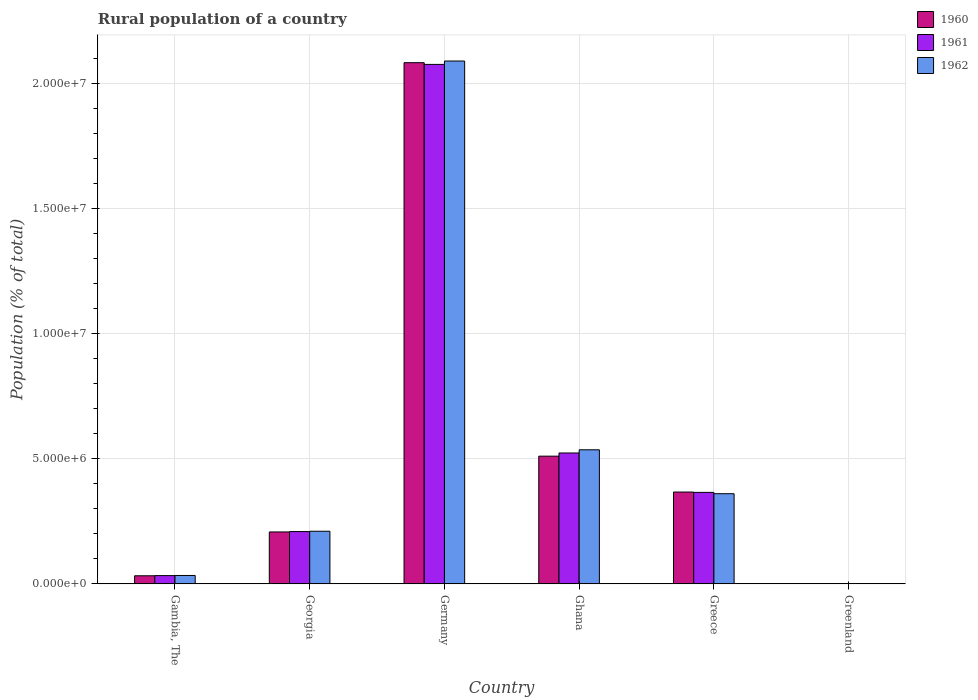Are the number of bars on each tick of the X-axis equal?
Keep it short and to the point. Yes. How many bars are there on the 1st tick from the right?
Give a very brief answer. 3. In how many cases, is the number of bars for a given country not equal to the number of legend labels?
Provide a succinct answer. 0. What is the rural population in 1962 in Ghana?
Give a very brief answer. 5.36e+06. Across all countries, what is the maximum rural population in 1962?
Ensure brevity in your answer.  2.09e+07. Across all countries, what is the minimum rural population in 1962?
Offer a very short reply. 1.35e+04. In which country was the rural population in 1960 maximum?
Make the answer very short. Germany. In which country was the rural population in 1962 minimum?
Make the answer very short. Greenland. What is the total rural population in 1961 in the graph?
Your answer should be very brief. 3.21e+07. What is the difference between the rural population in 1960 in Gambia, The and that in Greenland?
Your response must be concise. 3.10e+05. What is the difference between the rural population in 1960 in Greenland and the rural population in 1962 in Gambia, The?
Make the answer very short. -3.22e+05. What is the average rural population in 1960 per country?
Your answer should be very brief. 5.34e+06. What is the difference between the rural population of/in 1960 and rural population of/in 1962 in Gambia, The?
Your answer should be compact. -1.21e+04. What is the ratio of the rural population in 1960 in Gambia, The to that in Greece?
Offer a very short reply. 0.09. Is the rural population in 1962 in Georgia less than that in Germany?
Your answer should be very brief. Yes. What is the difference between the highest and the second highest rural population in 1962?
Keep it short and to the point. -1.73e+07. What is the difference between the highest and the lowest rural population in 1961?
Keep it short and to the point. 2.08e+07. In how many countries, is the rural population in 1960 greater than the average rural population in 1960 taken over all countries?
Make the answer very short. 1. What does the 1st bar from the left in Greece represents?
Provide a succinct answer. 1960. How many bars are there?
Offer a terse response. 18. Are all the bars in the graph horizontal?
Make the answer very short. No. Are the values on the major ticks of Y-axis written in scientific E-notation?
Your answer should be very brief. Yes. Does the graph contain any zero values?
Your response must be concise. No. Does the graph contain grids?
Provide a short and direct response. Yes. Where does the legend appear in the graph?
Keep it short and to the point. Top right. How many legend labels are there?
Offer a very short reply. 3. What is the title of the graph?
Provide a short and direct response. Rural population of a country. What is the label or title of the Y-axis?
Offer a terse response. Population (% of total). What is the Population (% of total) of 1960 in Gambia, The?
Make the answer very short. 3.23e+05. What is the Population (% of total) of 1961 in Gambia, The?
Keep it short and to the point. 3.30e+05. What is the Population (% of total) of 1962 in Gambia, The?
Your answer should be very brief. 3.35e+05. What is the Population (% of total) in 1960 in Georgia?
Your answer should be compact. 2.08e+06. What is the Population (% of total) of 1961 in Georgia?
Offer a terse response. 2.09e+06. What is the Population (% of total) of 1962 in Georgia?
Make the answer very short. 2.10e+06. What is the Population (% of total) of 1960 in Germany?
Offer a terse response. 2.08e+07. What is the Population (% of total) of 1961 in Germany?
Keep it short and to the point. 2.08e+07. What is the Population (% of total) of 1962 in Germany?
Provide a short and direct response. 2.09e+07. What is the Population (% of total) in 1960 in Ghana?
Ensure brevity in your answer.  5.11e+06. What is the Population (% of total) of 1961 in Ghana?
Keep it short and to the point. 5.23e+06. What is the Population (% of total) of 1962 in Ghana?
Offer a very short reply. 5.36e+06. What is the Population (% of total) in 1960 in Greece?
Your answer should be very brief. 3.67e+06. What is the Population (% of total) in 1961 in Greece?
Make the answer very short. 3.66e+06. What is the Population (% of total) of 1962 in Greece?
Keep it short and to the point. 3.60e+06. What is the Population (% of total) in 1960 in Greenland?
Your answer should be very brief. 1.35e+04. What is the Population (% of total) in 1961 in Greenland?
Your answer should be very brief. 1.35e+04. What is the Population (% of total) in 1962 in Greenland?
Offer a very short reply. 1.35e+04. Across all countries, what is the maximum Population (% of total) in 1960?
Keep it short and to the point. 2.08e+07. Across all countries, what is the maximum Population (% of total) in 1961?
Offer a very short reply. 2.08e+07. Across all countries, what is the maximum Population (% of total) in 1962?
Provide a short and direct response. 2.09e+07. Across all countries, what is the minimum Population (% of total) of 1960?
Offer a very short reply. 1.35e+04. Across all countries, what is the minimum Population (% of total) of 1961?
Your response must be concise. 1.35e+04. Across all countries, what is the minimum Population (% of total) of 1962?
Your response must be concise. 1.35e+04. What is the total Population (% of total) in 1960 in the graph?
Provide a short and direct response. 3.20e+07. What is the total Population (% of total) in 1961 in the graph?
Provide a succinct answer. 3.21e+07. What is the total Population (% of total) in 1962 in the graph?
Provide a succinct answer. 3.23e+07. What is the difference between the Population (% of total) of 1960 in Gambia, The and that in Georgia?
Your response must be concise. -1.75e+06. What is the difference between the Population (% of total) of 1961 in Gambia, The and that in Georgia?
Your response must be concise. -1.76e+06. What is the difference between the Population (% of total) in 1962 in Gambia, The and that in Georgia?
Your answer should be compact. -1.77e+06. What is the difference between the Population (% of total) of 1960 in Gambia, The and that in Germany?
Keep it short and to the point. -2.05e+07. What is the difference between the Population (% of total) of 1961 in Gambia, The and that in Germany?
Keep it short and to the point. -2.04e+07. What is the difference between the Population (% of total) of 1962 in Gambia, The and that in Germany?
Your response must be concise. -2.06e+07. What is the difference between the Population (% of total) of 1960 in Gambia, The and that in Ghana?
Provide a short and direct response. -4.78e+06. What is the difference between the Population (% of total) in 1961 in Gambia, The and that in Ghana?
Your response must be concise. -4.90e+06. What is the difference between the Population (% of total) of 1962 in Gambia, The and that in Ghana?
Provide a succinct answer. -5.02e+06. What is the difference between the Population (% of total) of 1960 in Gambia, The and that in Greece?
Make the answer very short. -3.35e+06. What is the difference between the Population (% of total) in 1961 in Gambia, The and that in Greece?
Your response must be concise. -3.33e+06. What is the difference between the Population (% of total) in 1962 in Gambia, The and that in Greece?
Provide a short and direct response. -3.27e+06. What is the difference between the Population (% of total) in 1960 in Gambia, The and that in Greenland?
Offer a very short reply. 3.10e+05. What is the difference between the Population (% of total) in 1961 in Gambia, The and that in Greenland?
Your answer should be very brief. 3.17e+05. What is the difference between the Population (% of total) of 1962 in Gambia, The and that in Greenland?
Give a very brief answer. 3.22e+05. What is the difference between the Population (% of total) of 1960 in Georgia and that in Germany?
Provide a succinct answer. -1.88e+07. What is the difference between the Population (% of total) in 1961 in Georgia and that in Germany?
Give a very brief answer. -1.87e+07. What is the difference between the Population (% of total) in 1962 in Georgia and that in Germany?
Offer a very short reply. -1.88e+07. What is the difference between the Population (% of total) of 1960 in Georgia and that in Ghana?
Your response must be concise. -3.03e+06. What is the difference between the Population (% of total) in 1961 in Georgia and that in Ghana?
Make the answer very short. -3.14e+06. What is the difference between the Population (% of total) in 1962 in Georgia and that in Ghana?
Your answer should be very brief. -3.26e+06. What is the difference between the Population (% of total) of 1960 in Georgia and that in Greece?
Ensure brevity in your answer.  -1.60e+06. What is the difference between the Population (% of total) in 1961 in Georgia and that in Greece?
Your answer should be very brief. -1.57e+06. What is the difference between the Population (% of total) of 1962 in Georgia and that in Greece?
Your answer should be very brief. -1.50e+06. What is the difference between the Population (% of total) in 1960 in Georgia and that in Greenland?
Keep it short and to the point. 2.06e+06. What is the difference between the Population (% of total) of 1961 in Georgia and that in Greenland?
Make the answer very short. 2.08e+06. What is the difference between the Population (% of total) in 1962 in Georgia and that in Greenland?
Make the answer very short. 2.09e+06. What is the difference between the Population (% of total) of 1960 in Germany and that in Ghana?
Provide a short and direct response. 1.57e+07. What is the difference between the Population (% of total) of 1961 in Germany and that in Ghana?
Offer a very short reply. 1.55e+07. What is the difference between the Population (% of total) in 1962 in Germany and that in Ghana?
Your response must be concise. 1.55e+07. What is the difference between the Population (% of total) of 1960 in Germany and that in Greece?
Ensure brevity in your answer.  1.72e+07. What is the difference between the Population (% of total) in 1961 in Germany and that in Greece?
Offer a terse response. 1.71e+07. What is the difference between the Population (% of total) of 1962 in Germany and that in Greece?
Keep it short and to the point. 1.73e+07. What is the difference between the Population (% of total) in 1960 in Germany and that in Greenland?
Your answer should be compact. 2.08e+07. What is the difference between the Population (% of total) in 1961 in Germany and that in Greenland?
Your answer should be compact. 2.08e+07. What is the difference between the Population (% of total) of 1962 in Germany and that in Greenland?
Keep it short and to the point. 2.09e+07. What is the difference between the Population (% of total) in 1960 in Ghana and that in Greece?
Make the answer very short. 1.43e+06. What is the difference between the Population (% of total) of 1961 in Ghana and that in Greece?
Keep it short and to the point. 1.58e+06. What is the difference between the Population (% of total) of 1962 in Ghana and that in Greece?
Make the answer very short. 1.76e+06. What is the difference between the Population (% of total) of 1960 in Ghana and that in Greenland?
Make the answer very short. 5.09e+06. What is the difference between the Population (% of total) of 1961 in Ghana and that in Greenland?
Make the answer very short. 5.22e+06. What is the difference between the Population (% of total) of 1962 in Ghana and that in Greenland?
Offer a terse response. 5.35e+06. What is the difference between the Population (% of total) in 1960 in Greece and that in Greenland?
Offer a terse response. 3.66e+06. What is the difference between the Population (% of total) in 1961 in Greece and that in Greenland?
Offer a terse response. 3.64e+06. What is the difference between the Population (% of total) of 1962 in Greece and that in Greenland?
Your answer should be very brief. 3.59e+06. What is the difference between the Population (% of total) in 1960 in Gambia, The and the Population (% of total) in 1961 in Georgia?
Provide a short and direct response. -1.77e+06. What is the difference between the Population (% of total) of 1960 in Gambia, The and the Population (% of total) of 1962 in Georgia?
Your response must be concise. -1.78e+06. What is the difference between the Population (% of total) in 1961 in Gambia, The and the Population (% of total) in 1962 in Georgia?
Ensure brevity in your answer.  -1.77e+06. What is the difference between the Population (% of total) in 1960 in Gambia, The and the Population (% of total) in 1961 in Germany?
Offer a terse response. -2.04e+07. What is the difference between the Population (% of total) in 1960 in Gambia, The and the Population (% of total) in 1962 in Germany?
Keep it short and to the point. -2.06e+07. What is the difference between the Population (% of total) in 1961 in Gambia, The and the Population (% of total) in 1962 in Germany?
Keep it short and to the point. -2.06e+07. What is the difference between the Population (% of total) in 1960 in Gambia, The and the Population (% of total) in 1961 in Ghana?
Your answer should be very brief. -4.91e+06. What is the difference between the Population (% of total) of 1960 in Gambia, The and the Population (% of total) of 1962 in Ghana?
Ensure brevity in your answer.  -5.04e+06. What is the difference between the Population (% of total) of 1961 in Gambia, The and the Population (% of total) of 1962 in Ghana?
Your answer should be compact. -5.03e+06. What is the difference between the Population (% of total) in 1960 in Gambia, The and the Population (% of total) in 1961 in Greece?
Make the answer very short. -3.33e+06. What is the difference between the Population (% of total) in 1960 in Gambia, The and the Population (% of total) in 1962 in Greece?
Provide a succinct answer. -3.28e+06. What is the difference between the Population (% of total) of 1961 in Gambia, The and the Population (% of total) of 1962 in Greece?
Offer a very short reply. -3.27e+06. What is the difference between the Population (% of total) of 1960 in Gambia, The and the Population (% of total) of 1961 in Greenland?
Offer a very short reply. 3.10e+05. What is the difference between the Population (% of total) in 1960 in Gambia, The and the Population (% of total) in 1962 in Greenland?
Provide a short and direct response. 3.10e+05. What is the difference between the Population (% of total) in 1961 in Gambia, The and the Population (% of total) in 1962 in Greenland?
Give a very brief answer. 3.17e+05. What is the difference between the Population (% of total) of 1960 in Georgia and the Population (% of total) of 1961 in Germany?
Provide a succinct answer. -1.87e+07. What is the difference between the Population (% of total) of 1960 in Georgia and the Population (% of total) of 1962 in Germany?
Ensure brevity in your answer.  -1.88e+07. What is the difference between the Population (% of total) of 1961 in Georgia and the Population (% of total) of 1962 in Germany?
Keep it short and to the point. -1.88e+07. What is the difference between the Population (% of total) of 1960 in Georgia and the Population (% of total) of 1961 in Ghana?
Provide a short and direct response. -3.16e+06. What is the difference between the Population (% of total) in 1960 in Georgia and the Population (% of total) in 1962 in Ghana?
Offer a very short reply. -3.28e+06. What is the difference between the Population (% of total) of 1961 in Georgia and the Population (% of total) of 1962 in Ghana?
Your answer should be very brief. -3.27e+06. What is the difference between the Population (% of total) of 1960 in Georgia and the Population (% of total) of 1961 in Greece?
Offer a terse response. -1.58e+06. What is the difference between the Population (% of total) of 1960 in Georgia and the Population (% of total) of 1962 in Greece?
Your answer should be very brief. -1.53e+06. What is the difference between the Population (% of total) of 1961 in Georgia and the Population (% of total) of 1962 in Greece?
Your response must be concise. -1.51e+06. What is the difference between the Population (% of total) of 1960 in Georgia and the Population (% of total) of 1961 in Greenland?
Your response must be concise. 2.06e+06. What is the difference between the Population (% of total) of 1960 in Georgia and the Population (% of total) of 1962 in Greenland?
Your answer should be compact. 2.06e+06. What is the difference between the Population (% of total) of 1961 in Georgia and the Population (% of total) of 1962 in Greenland?
Offer a very short reply. 2.08e+06. What is the difference between the Population (% of total) of 1960 in Germany and the Population (% of total) of 1961 in Ghana?
Your answer should be very brief. 1.56e+07. What is the difference between the Population (% of total) in 1960 in Germany and the Population (% of total) in 1962 in Ghana?
Provide a succinct answer. 1.55e+07. What is the difference between the Population (% of total) of 1961 in Germany and the Population (% of total) of 1962 in Ghana?
Offer a very short reply. 1.54e+07. What is the difference between the Population (% of total) in 1960 in Germany and the Population (% of total) in 1961 in Greece?
Keep it short and to the point. 1.72e+07. What is the difference between the Population (% of total) in 1960 in Germany and the Population (% of total) in 1962 in Greece?
Keep it short and to the point. 1.72e+07. What is the difference between the Population (% of total) in 1961 in Germany and the Population (% of total) in 1962 in Greece?
Offer a terse response. 1.72e+07. What is the difference between the Population (% of total) in 1960 in Germany and the Population (% of total) in 1961 in Greenland?
Your answer should be compact. 2.08e+07. What is the difference between the Population (% of total) of 1960 in Germany and the Population (% of total) of 1962 in Greenland?
Provide a succinct answer. 2.08e+07. What is the difference between the Population (% of total) of 1961 in Germany and the Population (% of total) of 1962 in Greenland?
Offer a very short reply. 2.08e+07. What is the difference between the Population (% of total) in 1960 in Ghana and the Population (% of total) in 1961 in Greece?
Offer a very short reply. 1.45e+06. What is the difference between the Population (% of total) in 1960 in Ghana and the Population (% of total) in 1962 in Greece?
Give a very brief answer. 1.50e+06. What is the difference between the Population (% of total) of 1961 in Ghana and the Population (% of total) of 1962 in Greece?
Keep it short and to the point. 1.63e+06. What is the difference between the Population (% of total) in 1960 in Ghana and the Population (% of total) in 1961 in Greenland?
Offer a very short reply. 5.09e+06. What is the difference between the Population (% of total) in 1960 in Ghana and the Population (% of total) in 1962 in Greenland?
Keep it short and to the point. 5.09e+06. What is the difference between the Population (% of total) in 1961 in Ghana and the Population (% of total) in 1962 in Greenland?
Keep it short and to the point. 5.22e+06. What is the difference between the Population (% of total) in 1960 in Greece and the Population (% of total) in 1961 in Greenland?
Offer a very short reply. 3.66e+06. What is the difference between the Population (% of total) of 1960 in Greece and the Population (% of total) of 1962 in Greenland?
Keep it short and to the point. 3.66e+06. What is the difference between the Population (% of total) in 1961 in Greece and the Population (% of total) in 1962 in Greenland?
Offer a terse response. 3.64e+06. What is the average Population (% of total) in 1960 per country?
Make the answer very short. 5.34e+06. What is the average Population (% of total) of 1961 per country?
Your answer should be compact. 5.35e+06. What is the average Population (% of total) of 1962 per country?
Provide a short and direct response. 5.39e+06. What is the difference between the Population (% of total) of 1960 and Population (% of total) of 1961 in Gambia, The?
Offer a terse response. -6978. What is the difference between the Population (% of total) in 1960 and Population (% of total) in 1962 in Gambia, The?
Your response must be concise. -1.21e+04. What is the difference between the Population (% of total) of 1961 and Population (% of total) of 1962 in Gambia, The?
Provide a succinct answer. -5169. What is the difference between the Population (% of total) of 1960 and Population (% of total) of 1961 in Georgia?
Provide a succinct answer. -1.49e+04. What is the difference between the Population (% of total) of 1960 and Population (% of total) of 1962 in Georgia?
Provide a short and direct response. -2.84e+04. What is the difference between the Population (% of total) of 1961 and Population (% of total) of 1962 in Georgia?
Provide a succinct answer. -1.35e+04. What is the difference between the Population (% of total) in 1960 and Population (% of total) in 1961 in Germany?
Your answer should be compact. 6.86e+04. What is the difference between the Population (% of total) of 1960 and Population (% of total) of 1962 in Germany?
Your answer should be very brief. -6.67e+04. What is the difference between the Population (% of total) in 1961 and Population (% of total) in 1962 in Germany?
Keep it short and to the point. -1.35e+05. What is the difference between the Population (% of total) of 1960 and Population (% of total) of 1961 in Ghana?
Give a very brief answer. -1.27e+05. What is the difference between the Population (% of total) in 1960 and Population (% of total) in 1962 in Ghana?
Offer a very short reply. -2.55e+05. What is the difference between the Population (% of total) in 1961 and Population (% of total) in 1962 in Ghana?
Your response must be concise. -1.27e+05. What is the difference between the Population (% of total) of 1960 and Population (% of total) of 1961 in Greece?
Offer a terse response. 1.42e+04. What is the difference between the Population (% of total) of 1960 and Population (% of total) of 1962 in Greece?
Provide a short and direct response. 6.73e+04. What is the difference between the Population (% of total) in 1961 and Population (% of total) in 1962 in Greece?
Provide a short and direct response. 5.31e+04. What is the difference between the Population (% of total) in 1960 and Population (% of total) in 1961 in Greenland?
Keep it short and to the point. -69. What is the difference between the Population (% of total) in 1960 and Population (% of total) in 1962 in Greenland?
Ensure brevity in your answer.  -32. What is the ratio of the Population (% of total) in 1960 in Gambia, The to that in Georgia?
Your answer should be very brief. 0.16. What is the ratio of the Population (% of total) in 1961 in Gambia, The to that in Georgia?
Your response must be concise. 0.16. What is the ratio of the Population (% of total) of 1962 in Gambia, The to that in Georgia?
Give a very brief answer. 0.16. What is the ratio of the Population (% of total) in 1960 in Gambia, The to that in Germany?
Offer a very short reply. 0.02. What is the ratio of the Population (% of total) in 1961 in Gambia, The to that in Germany?
Your answer should be compact. 0.02. What is the ratio of the Population (% of total) of 1962 in Gambia, The to that in Germany?
Your response must be concise. 0.02. What is the ratio of the Population (% of total) in 1960 in Gambia, The to that in Ghana?
Your answer should be compact. 0.06. What is the ratio of the Population (% of total) of 1961 in Gambia, The to that in Ghana?
Your answer should be compact. 0.06. What is the ratio of the Population (% of total) of 1962 in Gambia, The to that in Ghana?
Give a very brief answer. 0.06. What is the ratio of the Population (% of total) in 1960 in Gambia, The to that in Greece?
Give a very brief answer. 0.09. What is the ratio of the Population (% of total) of 1961 in Gambia, The to that in Greece?
Your response must be concise. 0.09. What is the ratio of the Population (% of total) in 1962 in Gambia, The to that in Greece?
Your response must be concise. 0.09. What is the ratio of the Population (% of total) of 1960 in Gambia, The to that in Greenland?
Offer a terse response. 23.99. What is the ratio of the Population (% of total) in 1961 in Gambia, The to that in Greenland?
Provide a short and direct response. 24.38. What is the ratio of the Population (% of total) in 1962 in Gambia, The to that in Greenland?
Ensure brevity in your answer.  24.83. What is the ratio of the Population (% of total) in 1960 in Georgia to that in Germany?
Offer a very short reply. 0.1. What is the ratio of the Population (% of total) of 1961 in Georgia to that in Germany?
Keep it short and to the point. 0.1. What is the ratio of the Population (% of total) of 1962 in Georgia to that in Germany?
Provide a succinct answer. 0.1. What is the ratio of the Population (% of total) of 1960 in Georgia to that in Ghana?
Your answer should be very brief. 0.41. What is the ratio of the Population (% of total) of 1961 in Georgia to that in Ghana?
Keep it short and to the point. 0.4. What is the ratio of the Population (% of total) in 1962 in Georgia to that in Ghana?
Your response must be concise. 0.39. What is the ratio of the Population (% of total) in 1960 in Georgia to that in Greece?
Provide a short and direct response. 0.57. What is the ratio of the Population (% of total) in 1961 in Georgia to that in Greece?
Provide a short and direct response. 0.57. What is the ratio of the Population (% of total) of 1962 in Georgia to that in Greece?
Offer a terse response. 0.58. What is the ratio of the Population (% of total) in 1960 in Georgia to that in Greenland?
Provide a short and direct response. 154.01. What is the ratio of the Population (% of total) in 1961 in Georgia to that in Greenland?
Offer a very short reply. 154.33. What is the ratio of the Population (% of total) of 1962 in Georgia to that in Greenland?
Keep it short and to the point. 155.75. What is the ratio of the Population (% of total) in 1960 in Germany to that in Ghana?
Provide a succinct answer. 4.08. What is the ratio of the Population (% of total) of 1961 in Germany to that in Ghana?
Give a very brief answer. 3.97. What is the ratio of the Population (% of total) of 1962 in Germany to that in Ghana?
Your response must be concise. 3.9. What is the ratio of the Population (% of total) in 1960 in Germany to that in Greece?
Provide a short and direct response. 5.68. What is the ratio of the Population (% of total) in 1961 in Germany to that in Greece?
Provide a succinct answer. 5.68. What is the ratio of the Population (% of total) in 1962 in Germany to that in Greece?
Your answer should be very brief. 5.8. What is the ratio of the Population (% of total) in 1960 in Germany to that in Greenland?
Provide a succinct answer. 1546.21. What is the ratio of the Population (% of total) of 1961 in Germany to that in Greenland?
Offer a very short reply. 1533.26. What is the ratio of the Population (% of total) of 1962 in Germany to that in Greenland?
Provide a short and direct response. 1547.48. What is the ratio of the Population (% of total) of 1960 in Ghana to that in Greece?
Give a very brief answer. 1.39. What is the ratio of the Population (% of total) in 1961 in Ghana to that in Greece?
Your response must be concise. 1.43. What is the ratio of the Population (% of total) in 1962 in Ghana to that in Greece?
Offer a terse response. 1.49. What is the ratio of the Population (% of total) in 1960 in Ghana to that in Greenland?
Give a very brief answer. 378.86. What is the ratio of the Population (% of total) in 1961 in Ghana to that in Greenland?
Provide a succinct answer. 386.31. What is the ratio of the Population (% of total) of 1962 in Ghana to that in Greenland?
Your answer should be compact. 396.8. What is the ratio of the Population (% of total) in 1960 in Greece to that in Greenland?
Your response must be concise. 272.43. What is the ratio of the Population (% of total) in 1961 in Greece to that in Greenland?
Ensure brevity in your answer.  270. What is the ratio of the Population (% of total) in 1962 in Greece to that in Greenland?
Make the answer very short. 266.81. What is the difference between the highest and the second highest Population (% of total) of 1960?
Your response must be concise. 1.57e+07. What is the difference between the highest and the second highest Population (% of total) of 1961?
Your response must be concise. 1.55e+07. What is the difference between the highest and the second highest Population (% of total) in 1962?
Make the answer very short. 1.55e+07. What is the difference between the highest and the lowest Population (% of total) of 1960?
Offer a terse response. 2.08e+07. What is the difference between the highest and the lowest Population (% of total) in 1961?
Your response must be concise. 2.08e+07. What is the difference between the highest and the lowest Population (% of total) of 1962?
Your answer should be compact. 2.09e+07. 